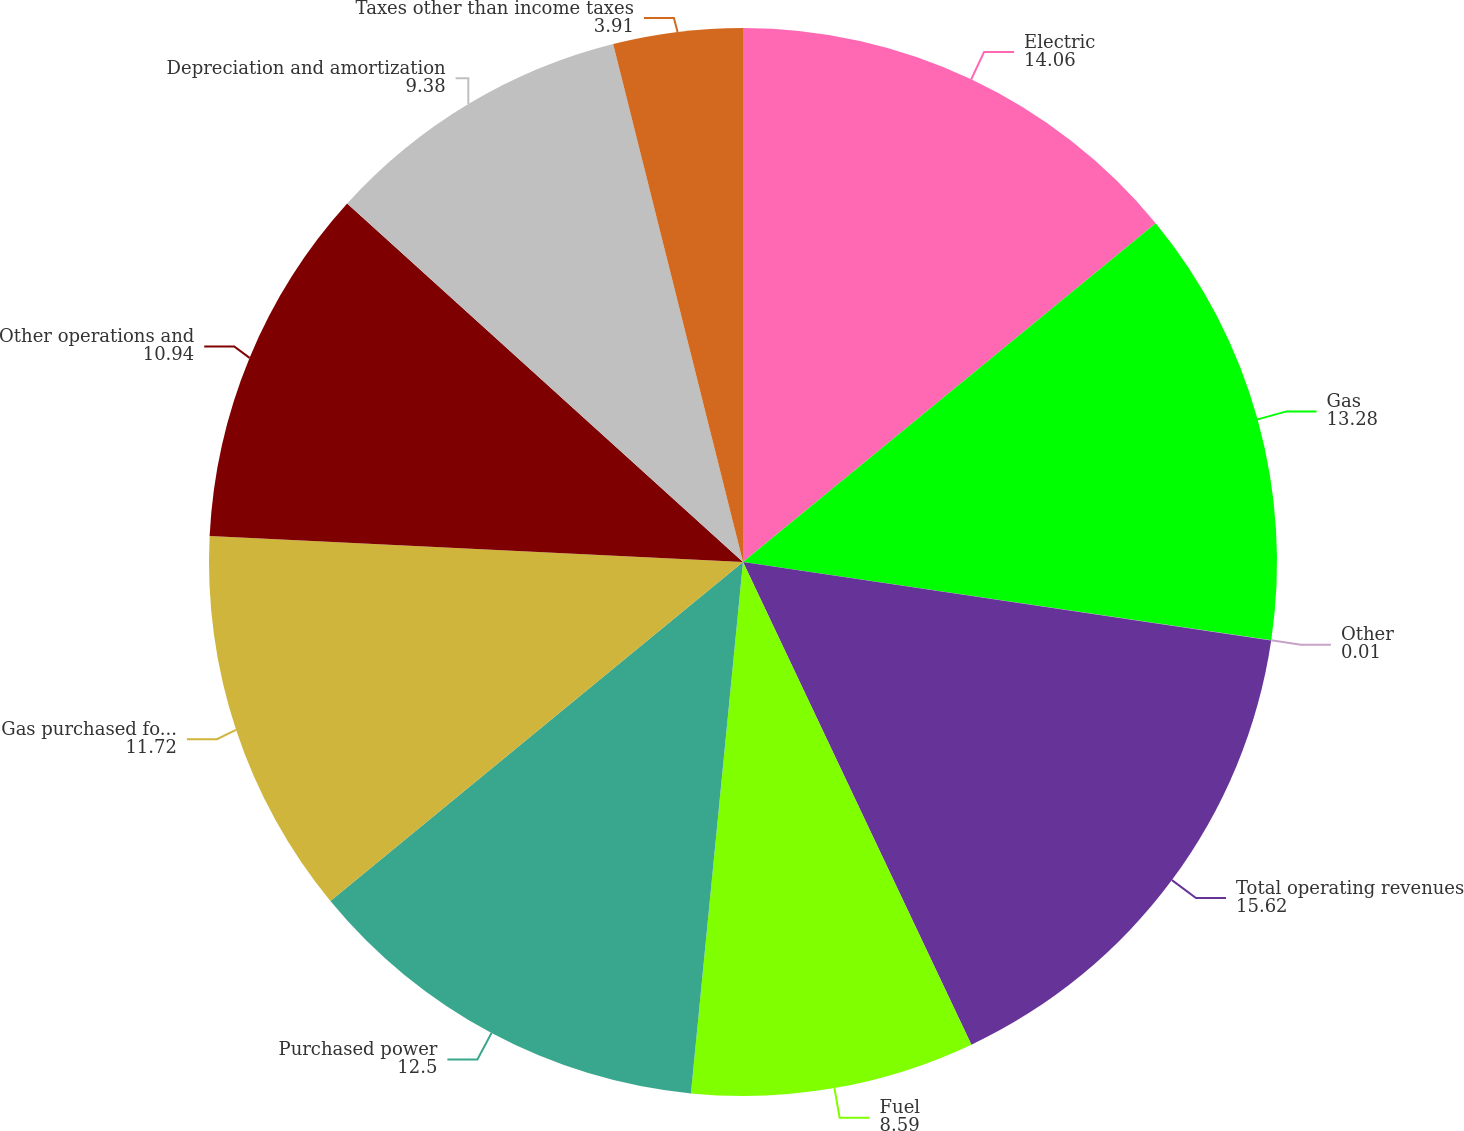Convert chart to OTSL. <chart><loc_0><loc_0><loc_500><loc_500><pie_chart><fcel>Electric<fcel>Gas<fcel>Other<fcel>Total operating revenues<fcel>Fuel<fcel>Purchased power<fcel>Gas purchased for resale<fcel>Other operations and<fcel>Depreciation and amortization<fcel>Taxes other than income taxes<nl><fcel>14.06%<fcel>13.28%<fcel>0.01%<fcel>15.62%<fcel>8.59%<fcel>12.5%<fcel>11.72%<fcel>10.94%<fcel>9.38%<fcel>3.91%<nl></chart> 